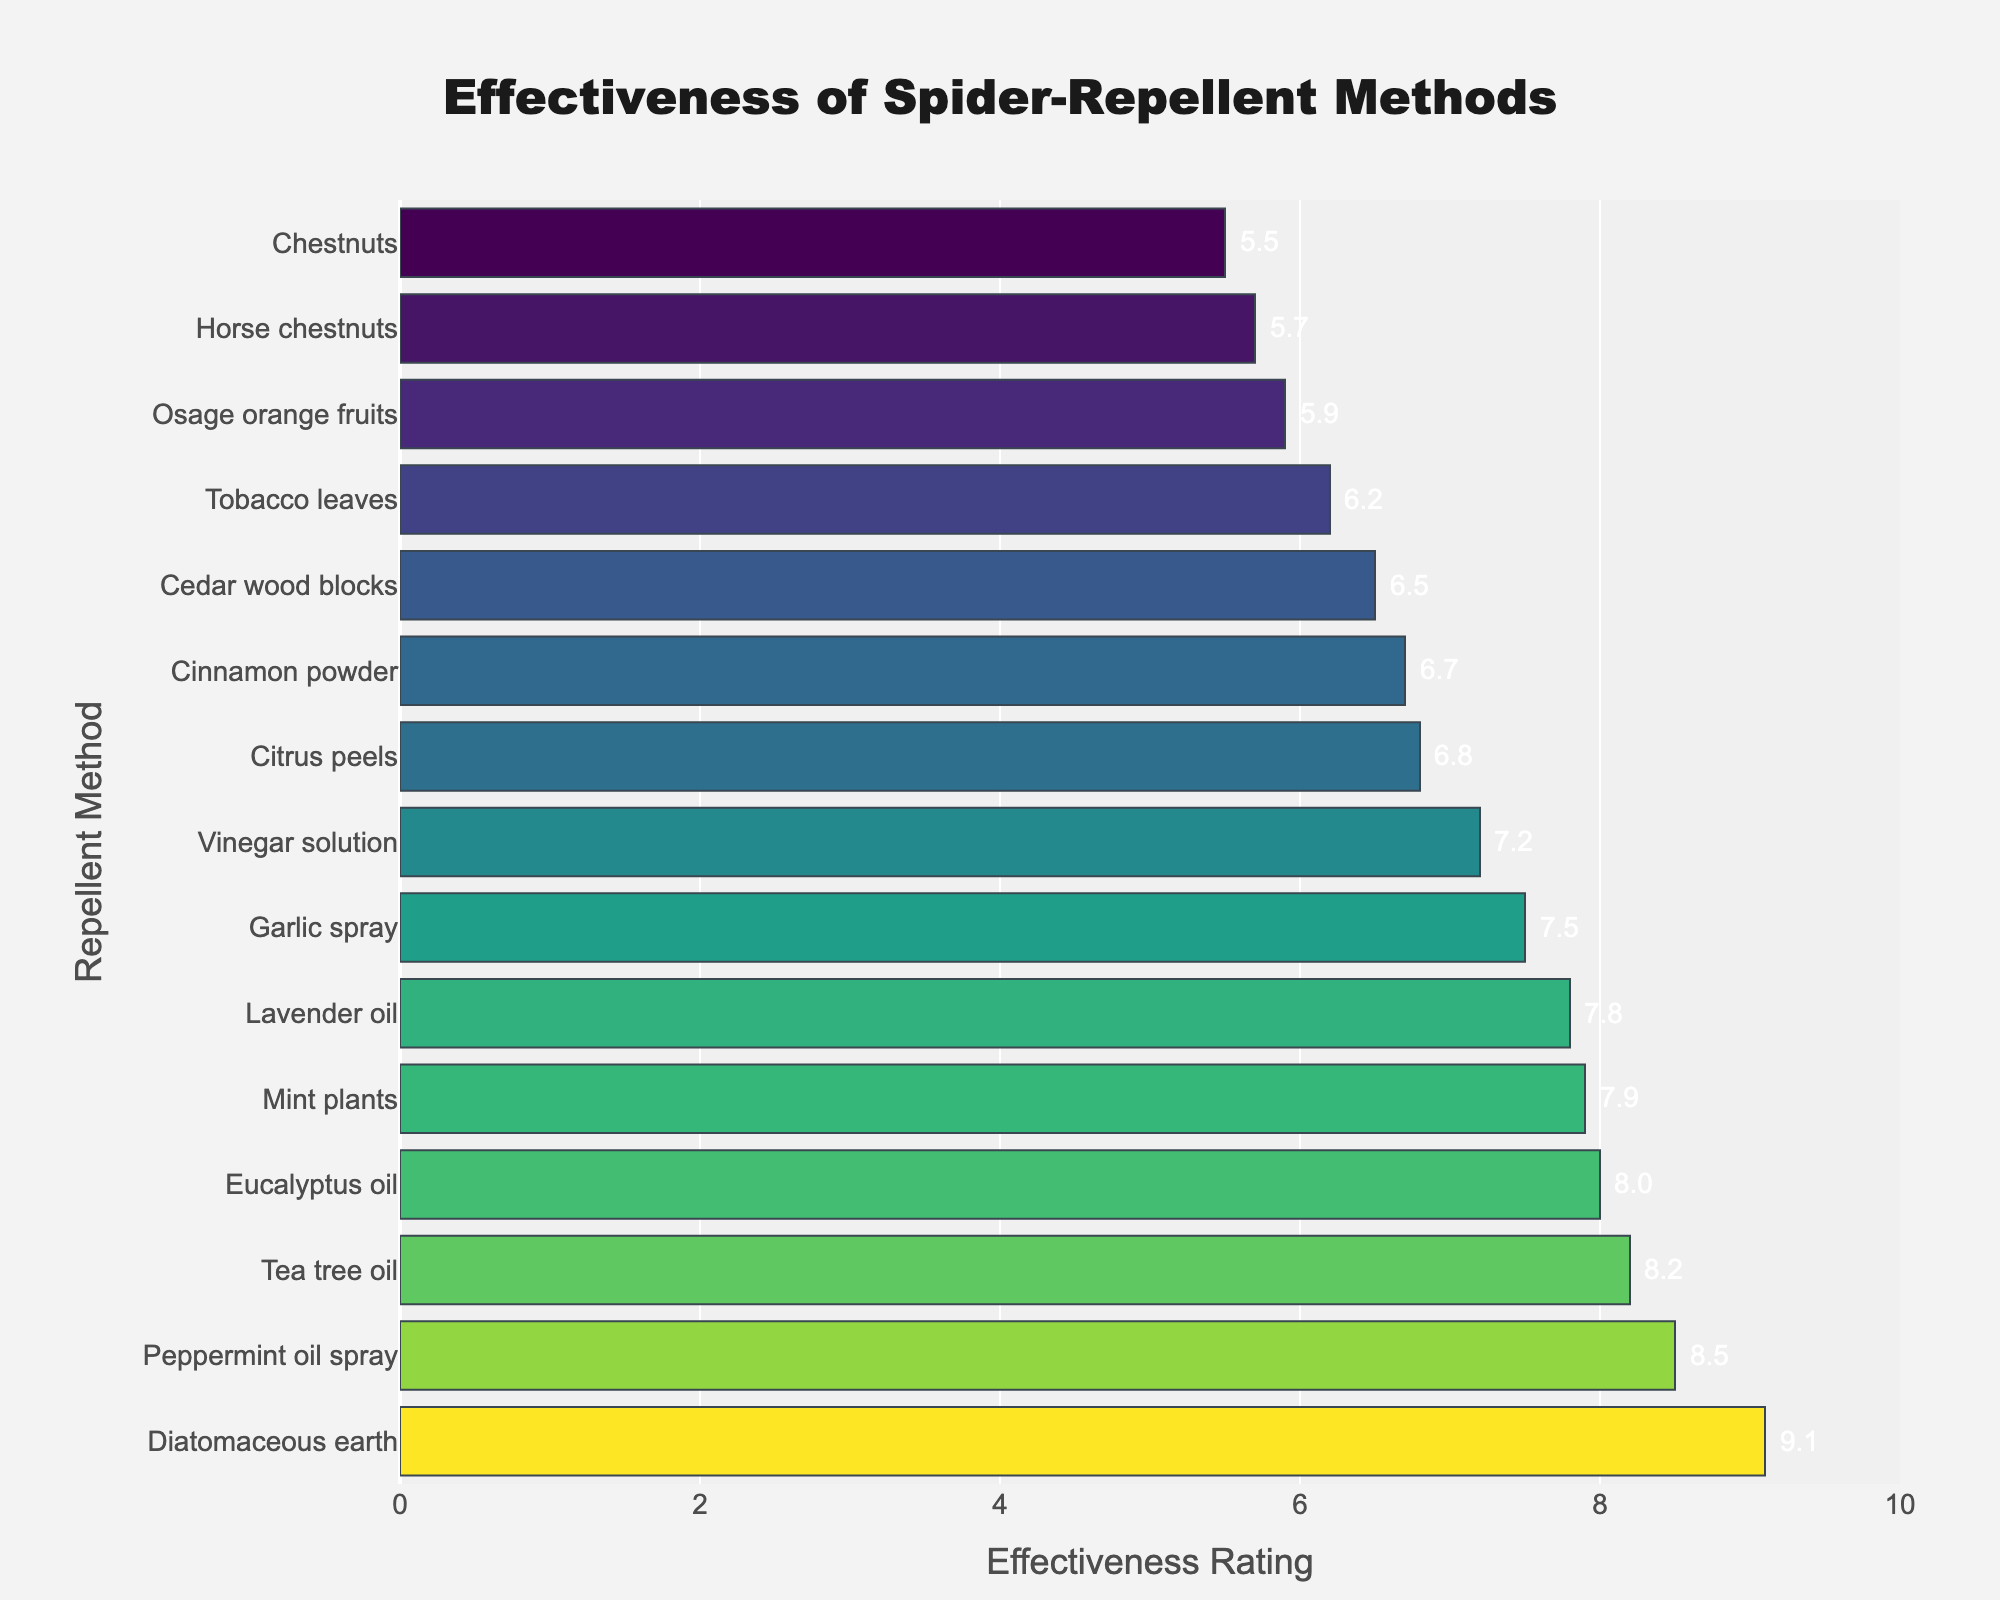What is the most effective spider-repellent method? The figure shows that Diatomaceous earth has the highest effectiveness rating.
Answer: Diatomaceous earth Which method is least effective in repelling spiders? The figure shows that Chestnuts have the lowest effectiveness rating.
Answer: Chestnuts What is the average effectiveness rating of all methods? Sum of all effectiveness ratings (8.5 + 7.2 + 9.1 + 6.8 + 8.0 + 5.5 + 7.8 + 6.5 + 5.9 + 6.2 + 7.5 + 6.7 + 7.9 + 5.7 + 8.2) is 107.4. There are 15 methods, so the average is 107.4 / 15.
Answer: 7.16 Which method is more effective, Tea tree oil or Mint plants? The figure shows that Tea tree oil has an effectiveness rating of 8.2, whereas Mint plants have a rating of 7.9.
Answer: Tea tree oil What is the total effectiveness rating of Lavender oil, Cinnamon powder, and Cedar wood blocks combined? Sum of the effectiveness ratings of Lavender oil (7.8), Cinnamon powder (6.7), and Cedar wood blocks (6.5) is 7.8 + 6.7 + 6.5.
Answer: 21.0 What is the difference in effectiveness between Eucalyptus oil and Garlic spray? The effectiveness rating for Eucalyptus oil is 8.0 and for Garlic spray is 7.5, so the difference is 8.0 - 7.5.
Answer: 0.5 How many methods have an effectiveness rating above 7.5? The figure shows that Peppermint oil spray (8.5), Diatomaceous earth (9.1), Eucalyptus oil (8.0), Lavender oil (7.8), Mint plants (7.9), and Tea tree oil (8.2) are above 7.5.
Answer: 6 What is the combined effectiveness rating of all methods rated exactly 6.5? The only method rated exactly 6.5 is Cedar wood blocks.
Answer: 6.5 Which method with the highest effectiveness rating also has a visual attribute of being the longest bar? The figure shows that Diatomaceous earth has the highest effectiveness rating and the longest bar.
Answer: Diatomaceous earth 